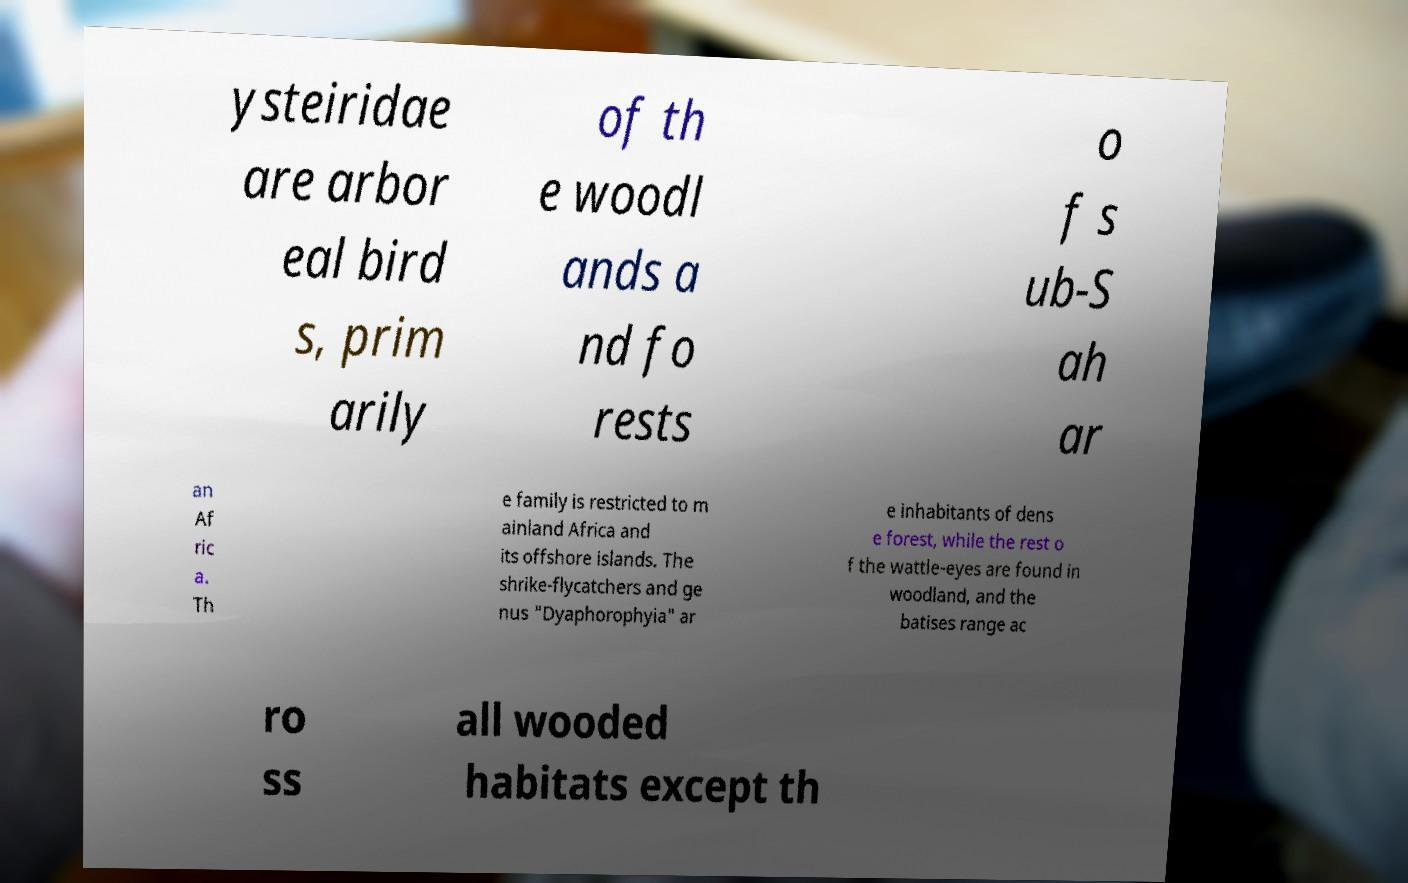Can you accurately transcribe the text from the provided image for me? ysteiridae are arbor eal bird s, prim arily of th e woodl ands a nd fo rests o f s ub-S ah ar an Af ric a. Th e family is restricted to m ainland Africa and its offshore islands. The shrike-flycatchers and ge nus "Dyaphorophyia" ar e inhabitants of dens e forest, while the rest o f the wattle-eyes are found in woodland, and the batises range ac ro ss all wooded habitats except th 